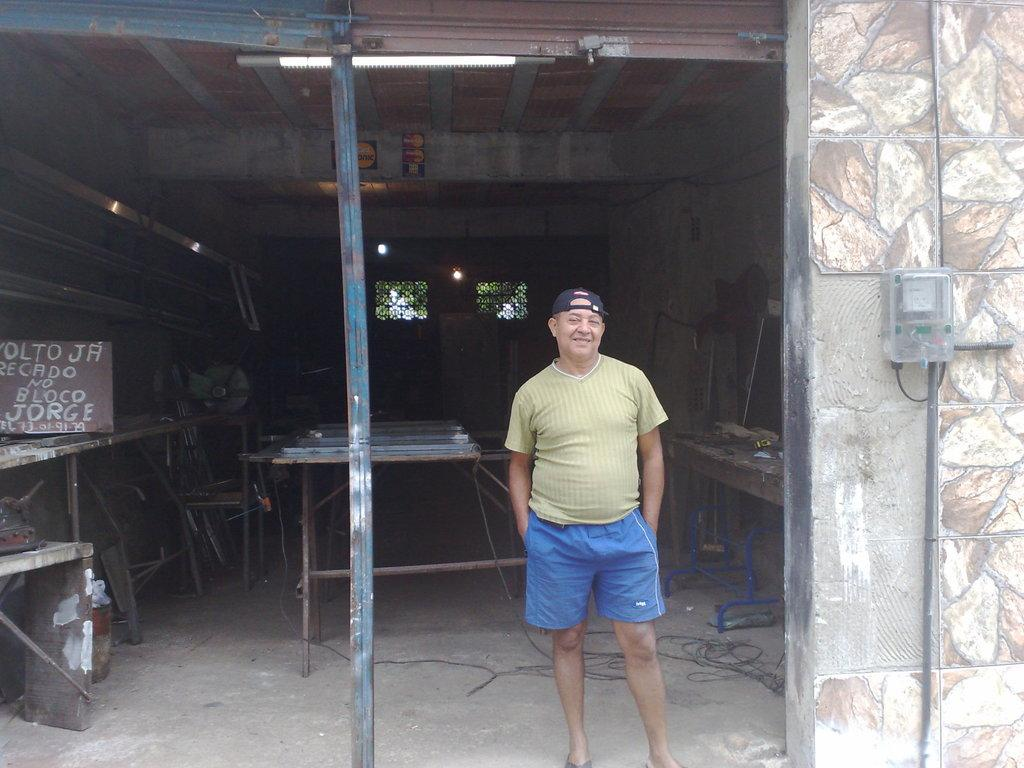Provide a one-sentence caption for the provided image. A handmade wooden sign includes the name Jorge on it in white lettering. 